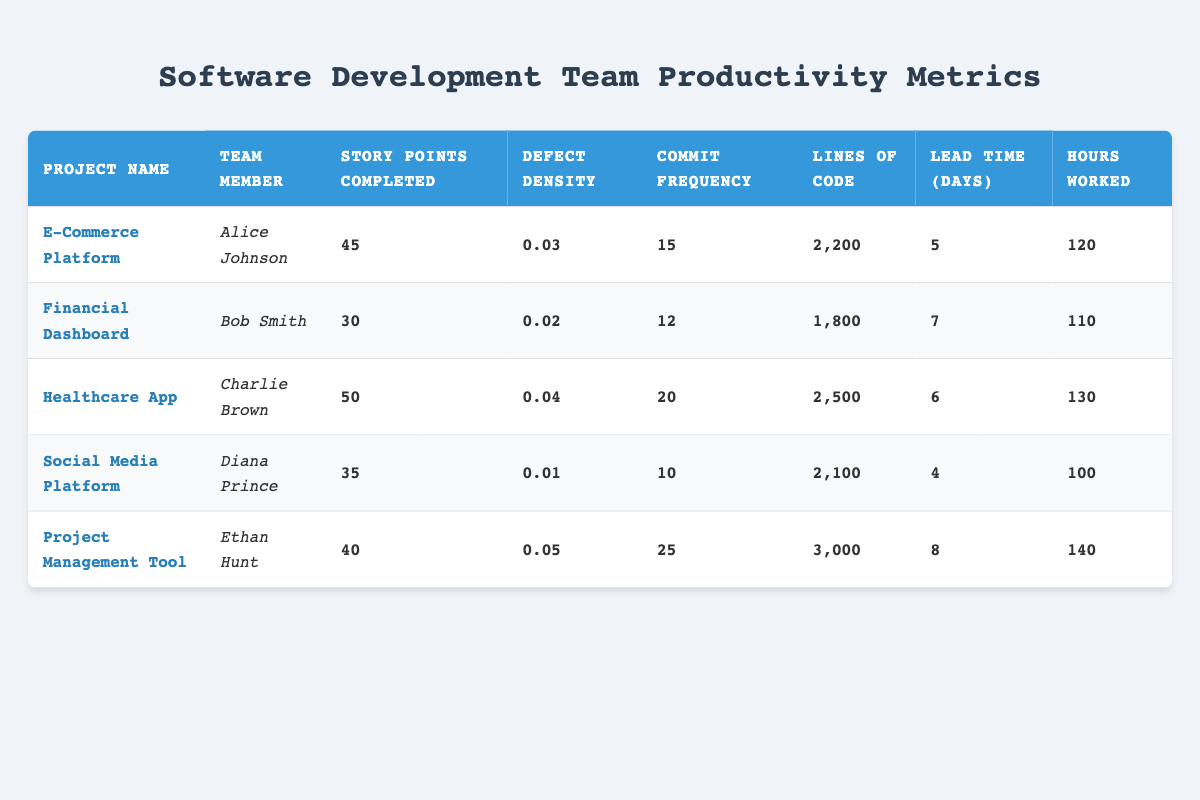What is the story points completed by Charlie Brown on the Healthcare App? The table lists Charlie Brown under the Healthcare App, and the corresponding value for story points completed in his row is 50.
Answer: 50 What is the defect density for the Social Media Platform? Looking at the row for the Social Media Platform, the defect density is listed as 0.01.
Answer: 0.01 Who has the highest commit frequency? Evaluating the commit frequencies, Ethan Hunt has 25 commits, which is greater than the others (15 for Alice, 12 for Bob, 20 for Charlie, and 10 for Diana), indicating he has the highest commit frequency.
Answer: Ethan Hunt What is the average lead time of all projects? First, we sum the lead times of all projects: 5 + 7 + 6 + 4 + 8 = 30. Then, we divide this total by the number of projects (5). Thus, the average lead time is 30 / 5 = 6.
Answer: 6 Is the defect density for the Financial Dashboard lower than 0.03? The defect density for the Financial Dashboard is 0.02, which is indeed lower than 0.03, confirming that the statement is true.
Answer: Yes Which project has the lowest story points completed? Reviewing the story points completed across all projects, Bob Smith's Financial Dashboard has the lowest value at 30 compared to the others.
Answer: Financial Dashboard What are the combined hours worked by Alice Johnson and Ethan Hunt? Alice worked 120 hours and Ethan worked 140 hours. Adding these two gives 120 + 140 = 260 hours.
Answer: 260 Which team member took the longest lead time for their project? Analyzing the lead times: Alice has 5, Bob has 7, Charlie has 6, Diana has 4, and Ethan has 8 days. Ethan's lead time of 8 days is the highest among all.
Answer: Ethan Hunt Which project has the most lines of code? Charlie Brown's Healthcare App indicates 2,500 lines of code, while the others show less: Alice has 2,200, Bob has 1,800, Diana has 2,100, and Ethan has 3,000. Comparing these, Ethan's Project Management Tool with 3,000 is the highest.
Answer: Project Management Tool 